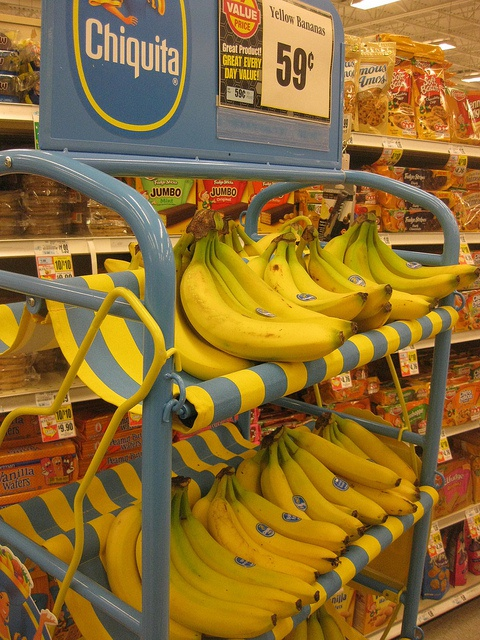Describe the objects in this image and their specific colors. I can see banana in tan, gold, and olive tones, banana in tan, olive, and orange tones, banana in tan, olive, and orange tones, banana in tan, gold, and olive tones, and banana in tan, olive, orange, and gold tones in this image. 